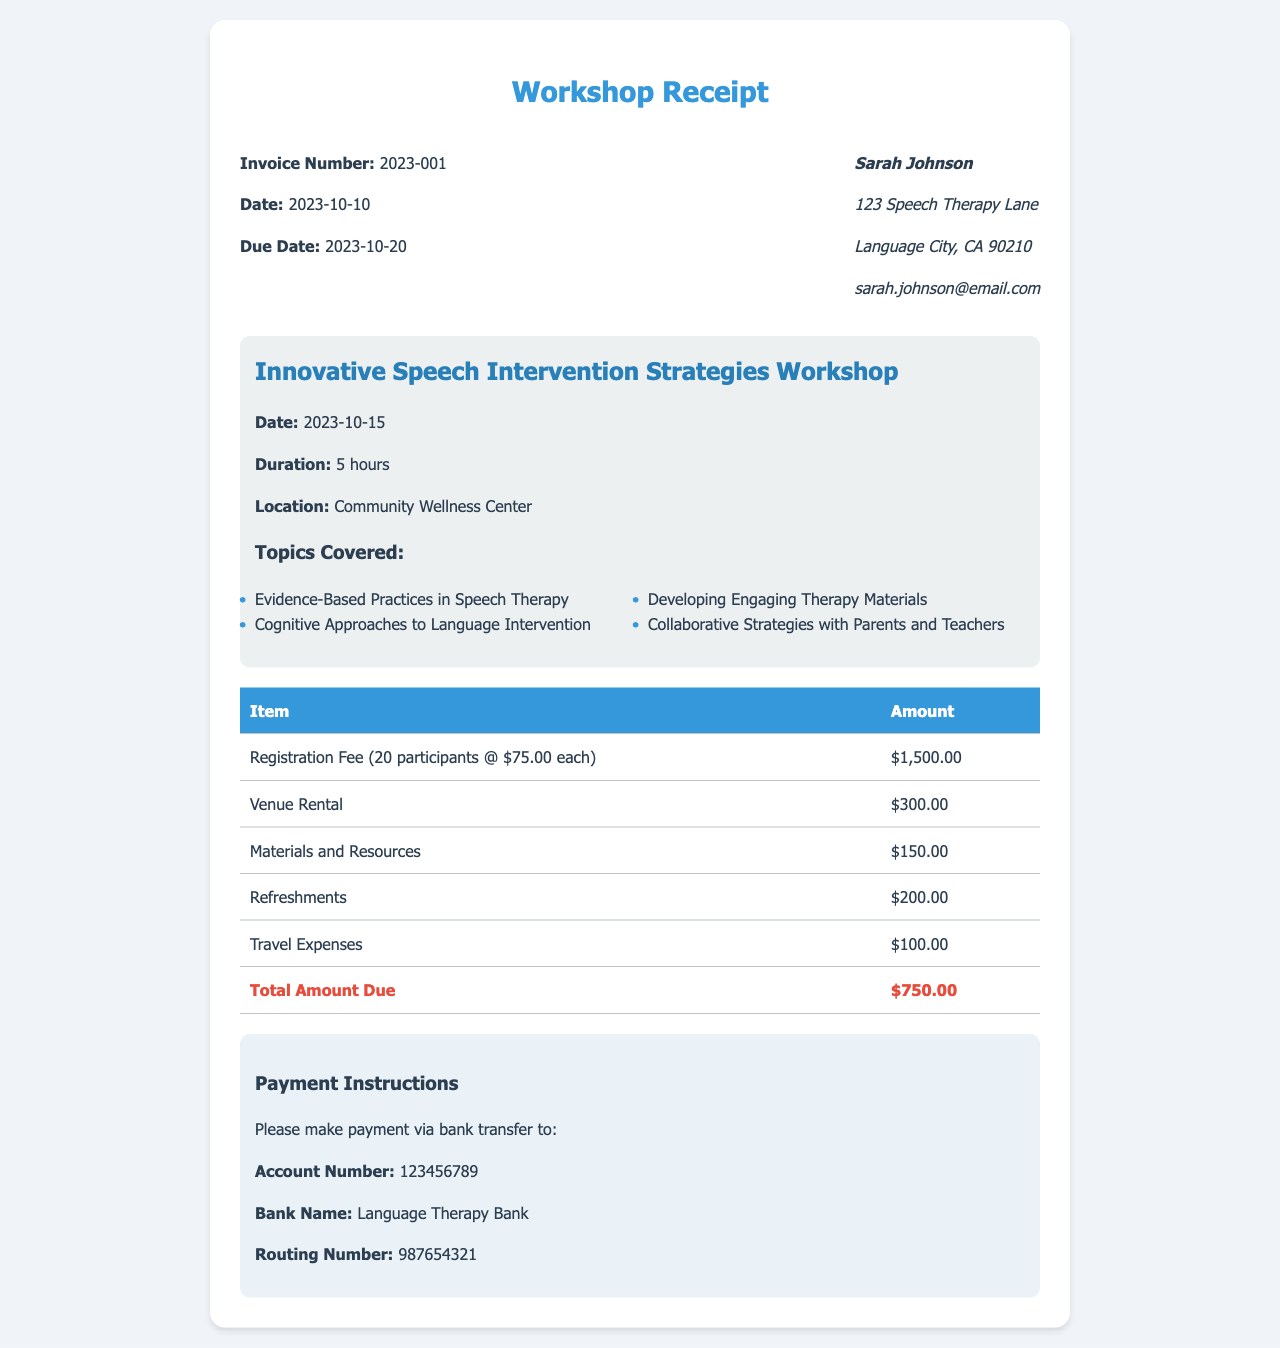What is the invoice number? The invoice number is stated at the top of the receipt, which identifies the transaction.
Answer: 2023-001 What is the total amount due? The total amount due is listed at the bottom of the itemized expenses table, summarizing the total cost of the workshop.
Answer: $750.00 What is the date of the workshop? The date of the workshop is specified within the workshop details section of the receipt.
Answer: 2023-10-15 How many participants are there? The document specifies the number of participants related to the registration fee item.
Answer: 20 participants What is the venue rental cost? The venue rental cost is one of the expenses itemized in the receipt.
Answer: $300.00 What are the payment instructions? The payment instructions provide specifics on how to pay the total amount due, including account details.
Answer: Bank transfer What is the duration of the workshop? The duration of the workshop is provided in the workshop details section to inform attendees about the length of the event.
Answer: 5 hours What are the topics covered in the workshop? The topics covered are listed under the workshop details, highlighting the focus areas of the event.
Answer: Evidence-Based Practices in Speech Therapy, Cognitive Approaches to Language Intervention, Developing Engaging Therapy Materials, Collaborative Strategies with Parents and Teachers When is the payment due? The due date for payment is indicated near the top of the receipt, serving as a deadline for the payment.
Answer: 2023-10-20 